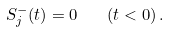Convert formula to latex. <formula><loc_0><loc_0><loc_500><loc_500>S _ { j } ^ { - } ( t ) = 0 \quad ( t < 0 ) \, .</formula> 